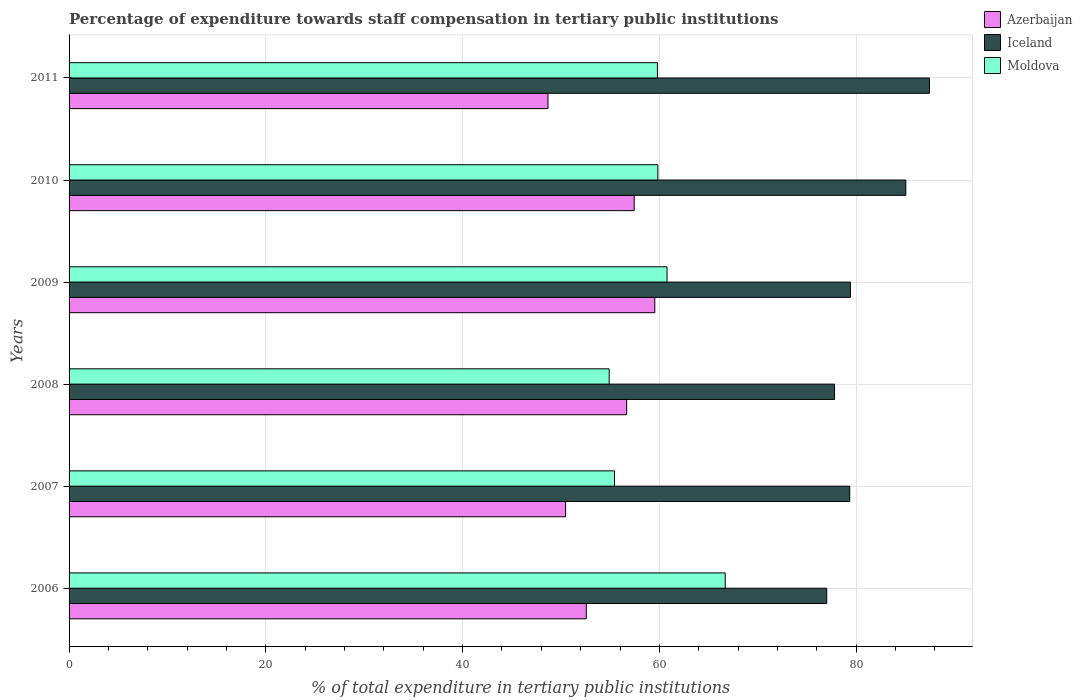How many different coloured bars are there?
Offer a very short reply. 3. How many bars are there on the 6th tick from the top?
Your answer should be very brief. 3. How many bars are there on the 4th tick from the bottom?
Your answer should be compact. 3. In how many cases, is the number of bars for a given year not equal to the number of legend labels?
Provide a short and direct response. 0. What is the percentage of expenditure towards staff compensation in Moldova in 2009?
Your response must be concise. 60.78. Across all years, what is the maximum percentage of expenditure towards staff compensation in Moldova?
Ensure brevity in your answer.  66.69. Across all years, what is the minimum percentage of expenditure towards staff compensation in Iceland?
Offer a very short reply. 77.01. In which year was the percentage of expenditure towards staff compensation in Moldova minimum?
Your response must be concise. 2008. What is the total percentage of expenditure towards staff compensation in Azerbaijan in the graph?
Your answer should be compact. 325.37. What is the difference between the percentage of expenditure towards staff compensation in Iceland in 2008 and that in 2010?
Make the answer very short. -7.24. What is the difference between the percentage of expenditure towards staff compensation in Azerbaijan in 2010 and the percentage of expenditure towards staff compensation in Iceland in 2011?
Ensure brevity in your answer.  -30.01. What is the average percentage of expenditure towards staff compensation in Iceland per year?
Your answer should be very brief. 81.01. In the year 2006, what is the difference between the percentage of expenditure towards staff compensation in Azerbaijan and percentage of expenditure towards staff compensation in Moldova?
Offer a terse response. -14.12. What is the ratio of the percentage of expenditure towards staff compensation in Moldova in 2007 to that in 2011?
Give a very brief answer. 0.93. Is the percentage of expenditure towards staff compensation in Azerbaijan in 2009 less than that in 2011?
Give a very brief answer. No. Is the difference between the percentage of expenditure towards staff compensation in Azerbaijan in 2008 and 2009 greater than the difference between the percentage of expenditure towards staff compensation in Moldova in 2008 and 2009?
Provide a succinct answer. Yes. What is the difference between the highest and the second highest percentage of expenditure towards staff compensation in Iceland?
Give a very brief answer. 2.4. What is the difference between the highest and the lowest percentage of expenditure towards staff compensation in Azerbaijan?
Ensure brevity in your answer.  10.86. What does the 2nd bar from the top in 2007 represents?
Offer a terse response. Iceland. What does the 2nd bar from the bottom in 2006 represents?
Your answer should be very brief. Iceland. How many years are there in the graph?
Your response must be concise. 6. Are the values on the major ticks of X-axis written in scientific E-notation?
Your answer should be very brief. No. How are the legend labels stacked?
Ensure brevity in your answer.  Vertical. What is the title of the graph?
Keep it short and to the point. Percentage of expenditure towards staff compensation in tertiary public institutions. What is the label or title of the X-axis?
Give a very brief answer. % of total expenditure in tertiary public institutions. What is the label or title of the Y-axis?
Keep it short and to the point. Years. What is the % of total expenditure in tertiary public institutions in Azerbaijan in 2006?
Give a very brief answer. 52.57. What is the % of total expenditure in tertiary public institutions in Iceland in 2006?
Offer a very short reply. 77.01. What is the % of total expenditure in tertiary public institutions in Moldova in 2006?
Provide a short and direct response. 66.69. What is the % of total expenditure in tertiary public institutions of Azerbaijan in 2007?
Ensure brevity in your answer.  50.47. What is the % of total expenditure in tertiary public institutions of Iceland in 2007?
Offer a terse response. 79.35. What is the % of total expenditure in tertiary public institutions of Moldova in 2007?
Provide a short and direct response. 55.44. What is the % of total expenditure in tertiary public institutions of Azerbaijan in 2008?
Provide a succinct answer. 56.67. What is the % of total expenditure in tertiary public institutions of Iceland in 2008?
Ensure brevity in your answer.  77.8. What is the % of total expenditure in tertiary public institutions of Moldova in 2008?
Provide a short and direct response. 54.9. What is the % of total expenditure in tertiary public institutions in Azerbaijan in 2009?
Provide a short and direct response. 59.54. What is the % of total expenditure in tertiary public institutions of Iceland in 2009?
Ensure brevity in your answer.  79.42. What is the % of total expenditure in tertiary public institutions in Moldova in 2009?
Provide a succinct answer. 60.78. What is the % of total expenditure in tertiary public institutions in Azerbaijan in 2010?
Provide a succinct answer. 57.44. What is the % of total expenditure in tertiary public institutions of Iceland in 2010?
Offer a terse response. 85.05. What is the % of total expenditure in tertiary public institutions of Moldova in 2010?
Make the answer very short. 59.85. What is the % of total expenditure in tertiary public institutions of Azerbaijan in 2011?
Your answer should be compact. 48.68. What is the % of total expenditure in tertiary public institutions of Iceland in 2011?
Give a very brief answer. 87.45. What is the % of total expenditure in tertiary public institutions in Moldova in 2011?
Make the answer very short. 59.8. Across all years, what is the maximum % of total expenditure in tertiary public institutions of Azerbaijan?
Your answer should be compact. 59.54. Across all years, what is the maximum % of total expenditure in tertiary public institutions in Iceland?
Make the answer very short. 87.45. Across all years, what is the maximum % of total expenditure in tertiary public institutions of Moldova?
Provide a succinct answer. 66.69. Across all years, what is the minimum % of total expenditure in tertiary public institutions of Azerbaijan?
Your response must be concise. 48.68. Across all years, what is the minimum % of total expenditure in tertiary public institutions of Iceland?
Offer a terse response. 77.01. Across all years, what is the minimum % of total expenditure in tertiary public institutions in Moldova?
Ensure brevity in your answer.  54.9. What is the total % of total expenditure in tertiary public institutions in Azerbaijan in the graph?
Your answer should be very brief. 325.37. What is the total % of total expenditure in tertiary public institutions in Iceland in the graph?
Your answer should be compact. 486.08. What is the total % of total expenditure in tertiary public institutions of Moldova in the graph?
Make the answer very short. 357.45. What is the difference between the % of total expenditure in tertiary public institutions of Azerbaijan in 2006 and that in 2007?
Your response must be concise. 2.1. What is the difference between the % of total expenditure in tertiary public institutions of Iceland in 2006 and that in 2007?
Ensure brevity in your answer.  -2.34. What is the difference between the % of total expenditure in tertiary public institutions in Moldova in 2006 and that in 2007?
Offer a very short reply. 11.25. What is the difference between the % of total expenditure in tertiary public institutions in Azerbaijan in 2006 and that in 2008?
Offer a very short reply. -4.1. What is the difference between the % of total expenditure in tertiary public institutions in Iceland in 2006 and that in 2008?
Provide a short and direct response. -0.79. What is the difference between the % of total expenditure in tertiary public institutions of Moldova in 2006 and that in 2008?
Your answer should be compact. 11.79. What is the difference between the % of total expenditure in tertiary public institutions of Azerbaijan in 2006 and that in 2009?
Provide a short and direct response. -6.96. What is the difference between the % of total expenditure in tertiary public institutions in Iceland in 2006 and that in 2009?
Give a very brief answer. -2.41. What is the difference between the % of total expenditure in tertiary public institutions of Moldova in 2006 and that in 2009?
Your response must be concise. 5.92. What is the difference between the % of total expenditure in tertiary public institutions in Azerbaijan in 2006 and that in 2010?
Provide a succinct answer. -4.87. What is the difference between the % of total expenditure in tertiary public institutions of Iceland in 2006 and that in 2010?
Your answer should be compact. -8.04. What is the difference between the % of total expenditure in tertiary public institutions in Moldova in 2006 and that in 2010?
Provide a short and direct response. 6.85. What is the difference between the % of total expenditure in tertiary public institutions of Azerbaijan in 2006 and that in 2011?
Make the answer very short. 3.89. What is the difference between the % of total expenditure in tertiary public institutions in Iceland in 2006 and that in 2011?
Keep it short and to the point. -10.44. What is the difference between the % of total expenditure in tertiary public institutions in Moldova in 2006 and that in 2011?
Provide a short and direct response. 6.89. What is the difference between the % of total expenditure in tertiary public institutions of Azerbaijan in 2007 and that in 2008?
Offer a very short reply. -6.2. What is the difference between the % of total expenditure in tertiary public institutions of Iceland in 2007 and that in 2008?
Your answer should be compact. 1.54. What is the difference between the % of total expenditure in tertiary public institutions of Moldova in 2007 and that in 2008?
Offer a very short reply. 0.54. What is the difference between the % of total expenditure in tertiary public institutions of Azerbaijan in 2007 and that in 2009?
Offer a terse response. -9.07. What is the difference between the % of total expenditure in tertiary public institutions of Iceland in 2007 and that in 2009?
Provide a short and direct response. -0.07. What is the difference between the % of total expenditure in tertiary public institutions of Moldova in 2007 and that in 2009?
Offer a very short reply. -5.34. What is the difference between the % of total expenditure in tertiary public institutions of Azerbaijan in 2007 and that in 2010?
Your answer should be very brief. -6.97. What is the difference between the % of total expenditure in tertiary public institutions of Iceland in 2007 and that in 2010?
Your answer should be very brief. -5.7. What is the difference between the % of total expenditure in tertiary public institutions of Moldova in 2007 and that in 2010?
Give a very brief answer. -4.41. What is the difference between the % of total expenditure in tertiary public institutions in Azerbaijan in 2007 and that in 2011?
Offer a terse response. 1.79. What is the difference between the % of total expenditure in tertiary public institutions in Iceland in 2007 and that in 2011?
Ensure brevity in your answer.  -8.1. What is the difference between the % of total expenditure in tertiary public institutions of Moldova in 2007 and that in 2011?
Offer a very short reply. -4.36. What is the difference between the % of total expenditure in tertiary public institutions in Azerbaijan in 2008 and that in 2009?
Ensure brevity in your answer.  -2.86. What is the difference between the % of total expenditure in tertiary public institutions in Iceland in 2008 and that in 2009?
Provide a short and direct response. -1.61. What is the difference between the % of total expenditure in tertiary public institutions of Moldova in 2008 and that in 2009?
Give a very brief answer. -5.88. What is the difference between the % of total expenditure in tertiary public institutions of Azerbaijan in 2008 and that in 2010?
Ensure brevity in your answer.  -0.77. What is the difference between the % of total expenditure in tertiary public institutions of Iceland in 2008 and that in 2010?
Ensure brevity in your answer.  -7.24. What is the difference between the % of total expenditure in tertiary public institutions in Moldova in 2008 and that in 2010?
Keep it short and to the point. -4.95. What is the difference between the % of total expenditure in tertiary public institutions in Azerbaijan in 2008 and that in 2011?
Your response must be concise. 7.99. What is the difference between the % of total expenditure in tertiary public institutions in Iceland in 2008 and that in 2011?
Provide a short and direct response. -9.65. What is the difference between the % of total expenditure in tertiary public institutions of Moldova in 2008 and that in 2011?
Provide a short and direct response. -4.9. What is the difference between the % of total expenditure in tertiary public institutions in Azerbaijan in 2009 and that in 2010?
Give a very brief answer. 2.09. What is the difference between the % of total expenditure in tertiary public institutions in Iceland in 2009 and that in 2010?
Your response must be concise. -5.63. What is the difference between the % of total expenditure in tertiary public institutions of Moldova in 2009 and that in 2010?
Ensure brevity in your answer.  0.93. What is the difference between the % of total expenditure in tertiary public institutions of Azerbaijan in 2009 and that in 2011?
Offer a terse response. 10.86. What is the difference between the % of total expenditure in tertiary public institutions in Iceland in 2009 and that in 2011?
Give a very brief answer. -8.04. What is the difference between the % of total expenditure in tertiary public institutions of Moldova in 2009 and that in 2011?
Offer a very short reply. 0.98. What is the difference between the % of total expenditure in tertiary public institutions of Azerbaijan in 2010 and that in 2011?
Make the answer very short. 8.76. What is the difference between the % of total expenditure in tertiary public institutions in Iceland in 2010 and that in 2011?
Provide a short and direct response. -2.4. What is the difference between the % of total expenditure in tertiary public institutions in Moldova in 2010 and that in 2011?
Keep it short and to the point. 0.04. What is the difference between the % of total expenditure in tertiary public institutions of Azerbaijan in 2006 and the % of total expenditure in tertiary public institutions of Iceland in 2007?
Provide a succinct answer. -26.78. What is the difference between the % of total expenditure in tertiary public institutions in Azerbaijan in 2006 and the % of total expenditure in tertiary public institutions in Moldova in 2007?
Your response must be concise. -2.87. What is the difference between the % of total expenditure in tertiary public institutions of Iceland in 2006 and the % of total expenditure in tertiary public institutions of Moldova in 2007?
Offer a terse response. 21.57. What is the difference between the % of total expenditure in tertiary public institutions in Azerbaijan in 2006 and the % of total expenditure in tertiary public institutions in Iceland in 2008?
Offer a terse response. -25.23. What is the difference between the % of total expenditure in tertiary public institutions of Azerbaijan in 2006 and the % of total expenditure in tertiary public institutions of Moldova in 2008?
Your answer should be very brief. -2.33. What is the difference between the % of total expenditure in tertiary public institutions of Iceland in 2006 and the % of total expenditure in tertiary public institutions of Moldova in 2008?
Offer a terse response. 22.11. What is the difference between the % of total expenditure in tertiary public institutions in Azerbaijan in 2006 and the % of total expenditure in tertiary public institutions in Iceland in 2009?
Your response must be concise. -26.85. What is the difference between the % of total expenditure in tertiary public institutions in Azerbaijan in 2006 and the % of total expenditure in tertiary public institutions in Moldova in 2009?
Your response must be concise. -8.21. What is the difference between the % of total expenditure in tertiary public institutions in Iceland in 2006 and the % of total expenditure in tertiary public institutions in Moldova in 2009?
Keep it short and to the point. 16.23. What is the difference between the % of total expenditure in tertiary public institutions of Azerbaijan in 2006 and the % of total expenditure in tertiary public institutions of Iceland in 2010?
Keep it short and to the point. -32.48. What is the difference between the % of total expenditure in tertiary public institutions of Azerbaijan in 2006 and the % of total expenditure in tertiary public institutions of Moldova in 2010?
Offer a terse response. -7.28. What is the difference between the % of total expenditure in tertiary public institutions in Iceland in 2006 and the % of total expenditure in tertiary public institutions in Moldova in 2010?
Keep it short and to the point. 17.16. What is the difference between the % of total expenditure in tertiary public institutions of Azerbaijan in 2006 and the % of total expenditure in tertiary public institutions of Iceland in 2011?
Your response must be concise. -34.88. What is the difference between the % of total expenditure in tertiary public institutions in Azerbaijan in 2006 and the % of total expenditure in tertiary public institutions in Moldova in 2011?
Keep it short and to the point. -7.23. What is the difference between the % of total expenditure in tertiary public institutions of Iceland in 2006 and the % of total expenditure in tertiary public institutions of Moldova in 2011?
Your answer should be compact. 17.21. What is the difference between the % of total expenditure in tertiary public institutions in Azerbaijan in 2007 and the % of total expenditure in tertiary public institutions in Iceland in 2008?
Your answer should be very brief. -27.34. What is the difference between the % of total expenditure in tertiary public institutions of Azerbaijan in 2007 and the % of total expenditure in tertiary public institutions of Moldova in 2008?
Give a very brief answer. -4.43. What is the difference between the % of total expenditure in tertiary public institutions of Iceland in 2007 and the % of total expenditure in tertiary public institutions of Moldova in 2008?
Give a very brief answer. 24.45. What is the difference between the % of total expenditure in tertiary public institutions of Azerbaijan in 2007 and the % of total expenditure in tertiary public institutions of Iceland in 2009?
Your response must be concise. -28.95. What is the difference between the % of total expenditure in tertiary public institutions in Azerbaijan in 2007 and the % of total expenditure in tertiary public institutions in Moldova in 2009?
Ensure brevity in your answer.  -10.31. What is the difference between the % of total expenditure in tertiary public institutions of Iceland in 2007 and the % of total expenditure in tertiary public institutions of Moldova in 2009?
Ensure brevity in your answer.  18.57. What is the difference between the % of total expenditure in tertiary public institutions in Azerbaijan in 2007 and the % of total expenditure in tertiary public institutions in Iceland in 2010?
Offer a very short reply. -34.58. What is the difference between the % of total expenditure in tertiary public institutions of Azerbaijan in 2007 and the % of total expenditure in tertiary public institutions of Moldova in 2010?
Your response must be concise. -9.38. What is the difference between the % of total expenditure in tertiary public institutions of Iceland in 2007 and the % of total expenditure in tertiary public institutions of Moldova in 2010?
Keep it short and to the point. 19.5. What is the difference between the % of total expenditure in tertiary public institutions of Azerbaijan in 2007 and the % of total expenditure in tertiary public institutions of Iceland in 2011?
Provide a succinct answer. -36.98. What is the difference between the % of total expenditure in tertiary public institutions in Azerbaijan in 2007 and the % of total expenditure in tertiary public institutions in Moldova in 2011?
Offer a terse response. -9.33. What is the difference between the % of total expenditure in tertiary public institutions in Iceland in 2007 and the % of total expenditure in tertiary public institutions in Moldova in 2011?
Your response must be concise. 19.55. What is the difference between the % of total expenditure in tertiary public institutions of Azerbaijan in 2008 and the % of total expenditure in tertiary public institutions of Iceland in 2009?
Keep it short and to the point. -22.74. What is the difference between the % of total expenditure in tertiary public institutions in Azerbaijan in 2008 and the % of total expenditure in tertiary public institutions in Moldova in 2009?
Your response must be concise. -4.1. What is the difference between the % of total expenditure in tertiary public institutions of Iceland in 2008 and the % of total expenditure in tertiary public institutions of Moldova in 2009?
Your response must be concise. 17.03. What is the difference between the % of total expenditure in tertiary public institutions of Azerbaijan in 2008 and the % of total expenditure in tertiary public institutions of Iceland in 2010?
Provide a succinct answer. -28.38. What is the difference between the % of total expenditure in tertiary public institutions of Azerbaijan in 2008 and the % of total expenditure in tertiary public institutions of Moldova in 2010?
Your answer should be very brief. -3.17. What is the difference between the % of total expenditure in tertiary public institutions in Iceland in 2008 and the % of total expenditure in tertiary public institutions in Moldova in 2010?
Offer a very short reply. 17.96. What is the difference between the % of total expenditure in tertiary public institutions of Azerbaijan in 2008 and the % of total expenditure in tertiary public institutions of Iceland in 2011?
Your answer should be compact. -30.78. What is the difference between the % of total expenditure in tertiary public institutions of Azerbaijan in 2008 and the % of total expenditure in tertiary public institutions of Moldova in 2011?
Your answer should be very brief. -3.13. What is the difference between the % of total expenditure in tertiary public institutions in Iceland in 2008 and the % of total expenditure in tertiary public institutions in Moldova in 2011?
Keep it short and to the point. 18. What is the difference between the % of total expenditure in tertiary public institutions of Azerbaijan in 2009 and the % of total expenditure in tertiary public institutions of Iceland in 2010?
Your response must be concise. -25.51. What is the difference between the % of total expenditure in tertiary public institutions in Azerbaijan in 2009 and the % of total expenditure in tertiary public institutions in Moldova in 2010?
Your response must be concise. -0.31. What is the difference between the % of total expenditure in tertiary public institutions of Iceland in 2009 and the % of total expenditure in tertiary public institutions of Moldova in 2010?
Give a very brief answer. 19.57. What is the difference between the % of total expenditure in tertiary public institutions of Azerbaijan in 2009 and the % of total expenditure in tertiary public institutions of Iceland in 2011?
Your answer should be very brief. -27.92. What is the difference between the % of total expenditure in tertiary public institutions in Azerbaijan in 2009 and the % of total expenditure in tertiary public institutions in Moldova in 2011?
Provide a short and direct response. -0.27. What is the difference between the % of total expenditure in tertiary public institutions in Iceland in 2009 and the % of total expenditure in tertiary public institutions in Moldova in 2011?
Provide a short and direct response. 19.62. What is the difference between the % of total expenditure in tertiary public institutions in Azerbaijan in 2010 and the % of total expenditure in tertiary public institutions in Iceland in 2011?
Your response must be concise. -30.01. What is the difference between the % of total expenditure in tertiary public institutions of Azerbaijan in 2010 and the % of total expenditure in tertiary public institutions of Moldova in 2011?
Offer a terse response. -2.36. What is the difference between the % of total expenditure in tertiary public institutions in Iceland in 2010 and the % of total expenditure in tertiary public institutions in Moldova in 2011?
Provide a succinct answer. 25.25. What is the average % of total expenditure in tertiary public institutions of Azerbaijan per year?
Your response must be concise. 54.23. What is the average % of total expenditure in tertiary public institutions in Iceland per year?
Give a very brief answer. 81.01. What is the average % of total expenditure in tertiary public institutions in Moldova per year?
Provide a succinct answer. 59.58. In the year 2006, what is the difference between the % of total expenditure in tertiary public institutions of Azerbaijan and % of total expenditure in tertiary public institutions of Iceland?
Provide a succinct answer. -24.44. In the year 2006, what is the difference between the % of total expenditure in tertiary public institutions of Azerbaijan and % of total expenditure in tertiary public institutions of Moldova?
Keep it short and to the point. -14.12. In the year 2006, what is the difference between the % of total expenditure in tertiary public institutions of Iceland and % of total expenditure in tertiary public institutions of Moldova?
Keep it short and to the point. 10.32. In the year 2007, what is the difference between the % of total expenditure in tertiary public institutions of Azerbaijan and % of total expenditure in tertiary public institutions of Iceland?
Make the answer very short. -28.88. In the year 2007, what is the difference between the % of total expenditure in tertiary public institutions in Azerbaijan and % of total expenditure in tertiary public institutions in Moldova?
Ensure brevity in your answer.  -4.97. In the year 2007, what is the difference between the % of total expenditure in tertiary public institutions of Iceland and % of total expenditure in tertiary public institutions of Moldova?
Provide a succinct answer. 23.91. In the year 2008, what is the difference between the % of total expenditure in tertiary public institutions in Azerbaijan and % of total expenditure in tertiary public institutions in Iceland?
Your response must be concise. -21.13. In the year 2008, what is the difference between the % of total expenditure in tertiary public institutions in Azerbaijan and % of total expenditure in tertiary public institutions in Moldova?
Your answer should be very brief. 1.77. In the year 2008, what is the difference between the % of total expenditure in tertiary public institutions in Iceland and % of total expenditure in tertiary public institutions in Moldova?
Your response must be concise. 22.91. In the year 2009, what is the difference between the % of total expenditure in tertiary public institutions of Azerbaijan and % of total expenditure in tertiary public institutions of Iceland?
Your response must be concise. -19.88. In the year 2009, what is the difference between the % of total expenditure in tertiary public institutions in Azerbaijan and % of total expenditure in tertiary public institutions in Moldova?
Offer a terse response. -1.24. In the year 2009, what is the difference between the % of total expenditure in tertiary public institutions in Iceland and % of total expenditure in tertiary public institutions in Moldova?
Keep it short and to the point. 18.64. In the year 2010, what is the difference between the % of total expenditure in tertiary public institutions of Azerbaijan and % of total expenditure in tertiary public institutions of Iceland?
Offer a very short reply. -27.61. In the year 2010, what is the difference between the % of total expenditure in tertiary public institutions of Azerbaijan and % of total expenditure in tertiary public institutions of Moldova?
Give a very brief answer. -2.4. In the year 2010, what is the difference between the % of total expenditure in tertiary public institutions in Iceland and % of total expenditure in tertiary public institutions in Moldova?
Your answer should be very brief. 25.2. In the year 2011, what is the difference between the % of total expenditure in tertiary public institutions of Azerbaijan and % of total expenditure in tertiary public institutions of Iceland?
Offer a very short reply. -38.77. In the year 2011, what is the difference between the % of total expenditure in tertiary public institutions of Azerbaijan and % of total expenditure in tertiary public institutions of Moldova?
Offer a very short reply. -11.12. In the year 2011, what is the difference between the % of total expenditure in tertiary public institutions in Iceland and % of total expenditure in tertiary public institutions in Moldova?
Make the answer very short. 27.65. What is the ratio of the % of total expenditure in tertiary public institutions in Azerbaijan in 2006 to that in 2007?
Your response must be concise. 1.04. What is the ratio of the % of total expenditure in tertiary public institutions in Iceland in 2006 to that in 2007?
Provide a short and direct response. 0.97. What is the ratio of the % of total expenditure in tertiary public institutions of Moldova in 2006 to that in 2007?
Give a very brief answer. 1.2. What is the ratio of the % of total expenditure in tertiary public institutions of Azerbaijan in 2006 to that in 2008?
Your response must be concise. 0.93. What is the ratio of the % of total expenditure in tertiary public institutions of Iceland in 2006 to that in 2008?
Your answer should be compact. 0.99. What is the ratio of the % of total expenditure in tertiary public institutions of Moldova in 2006 to that in 2008?
Your answer should be very brief. 1.21. What is the ratio of the % of total expenditure in tertiary public institutions in Azerbaijan in 2006 to that in 2009?
Your answer should be very brief. 0.88. What is the ratio of the % of total expenditure in tertiary public institutions in Iceland in 2006 to that in 2009?
Your response must be concise. 0.97. What is the ratio of the % of total expenditure in tertiary public institutions in Moldova in 2006 to that in 2009?
Provide a succinct answer. 1.1. What is the ratio of the % of total expenditure in tertiary public institutions of Azerbaijan in 2006 to that in 2010?
Provide a short and direct response. 0.92. What is the ratio of the % of total expenditure in tertiary public institutions of Iceland in 2006 to that in 2010?
Your answer should be compact. 0.91. What is the ratio of the % of total expenditure in tertiary public institutions in Moldova in 2006 to that in 2010?
Your answer should be compact. 1.11. What is the ratio of the % of total expenditure in tertiary public institutions of Azerbaijan in 2006 to that in 2011?
Provide a short and direct response. 1.08. What is the ratio of the % of total expenditure in tertiary public institutions of Iceland in 2006 to that in 2011?
Your answer should be compact. 0.88. What is the ratio of the % of total expenditure in tertiary public institutions of Moldova in 2006 to that in 2011?
Offer a very short reply. 1.12. What is the ratio of the % of total expenditure in tertiary public institutions in Azerbaijan in 2007 to that in 2008?
Keep it short and to the point. 0.89. What is the ratio of the % of total expenditure in tertiary public institutions in Iceland in 2007 to that in 2008?
Offer a very short reply. 1.02. What is the ratio of the % of total expenditure in tertiary public institutions in Moldova in 2007 to that in 2008?
Provide a short and direct response. 1.01. What is the ratio of the % of total expenditure in tertiary public institutions of Azerbaijan in 2007 to that in 2009?
Make the answer very short. 0.85. What is the ratio of the % of total expenditure in tertiary public institutions in Iceland in 2007 to that in 2009?
Provide a succinct answer. 1. What is the ratio of the % of total expenditure in tertiary public institutions of Moldova in 2007 to that in 2009?
Provide a succinct answer. 0.91. What is the ratio of the % of total expenditure in tertiary public institutions in Azerbaijan in 2007 to that in 2010?
Offer a terse response. 0.88. What is the ratio of the % of total expenditure in tertiary public institutions in Iceland in 2007 to that in 2010?
Your response must be concise. 0.93. What is the ratio of the % of total expenditure in tertiary public institutions of Moldova in 2007 to that in 2010?
Give a very brief answer. 0.93. What is the ratio of the % of total expenditure in tertiary public institutions of Azerbaijan in 2007 to that in 2011?
Your answer should be very brief. 1.04. What is the ratio of the % of total expenditure in tertiary public institutions of Iceland in 2007 to that in 2011?
Make the answer very short. 0.91. What is the ratio of the % of total expenditure in tertiary public institutions in Moldova in 2007 to that in 2011?
Provide a short and direct response. 0.93. What is the ratio of the % of total expenditure in tertiary public institutions of Azerbaijan in 2008 to that in 2009?
Keep it short and to the point. 0.95. What is the ratio of the % of total expenditure in tertiary public institutions of Iceland in 2008 to that in 2009?
Ensure brevity in your answer.  0.98. What is the ratio of the % of total expenditure in tertiary public institutions in Moldova in 2008 to that in 2009?
Your answer should be compact. 0.9. What is the ratio of the % of total expenditure in tertiary public institutions of Azerbaijan in 2008 to that in 2010?
Your response must be concise. 0.99. What is the ratio of the % of total expenditure in tertiary public institutions of Iceland in 2008 to that in 2010?
Make the answer very short. 0.91. What is the ratio of the % of total expenditure in tertiary public institutions of Moldova in 2008 to that in 2010?
Give a very brief answer. 0.92. What is the ratio of the % of total expenditure in tertiary public institutions in Azerbaijan in 2008 to that in 2011?
Give a very brief answer. 1.16. What is the ratio of the % of total expenditure in tertiary public institutions of Iceland in 2008 to that in 2011?
Ensure brevity in your answer.  0.89. What is the ratio of the % of total expenditure in tertiary public institutions in Moldova in 2008 to that in 2011?
Keep it short and to the point. 0.92. What is the ratio of the % of total expenditure in tertiary public institutions of Azerbaijan in 2009 to that in 2010?
Your answer should be very brief. 1.04. What is the ratio of the % of total expenditure in tertiary public institutions in Iceland in 2009 to that in 2010?
Offer a terse response. 0.93. What is the ratio of the % of total expenditure in tertiary public institutions in Moldova in 2009 to that in 2010?
Your response must be concise. 1.02. What is the ratio of the % of total expenditure in tertiary public institutions in Azerbaijan in 2009 to that in 2011?
Your response must be concise. 1.22. What is the ratio of the % of total expenditure in tertiary public institutions of Iceland in 2009 to that in 2011?
Your answer should be compact. 0.91. What is the ratio of the % of total expenditure in tertiary public institutions of Moldova in 2009 to that in 2011?
Keep it short and to the point. 1.02. What is the ratio of the % of total expenditure in tertiary public institutions in Azerbaijan in 2010 to that in 2011?
Provide a succinct answer. 1.18. What is the ratio of the % of total expenditure in tertiary public institutions of Iceland in 2010 to that in 2011?
Your response must be concise. 0.97. What is the difference between the highest and the second highest % of total expenditure in tertiary public institutions of Azerbaijan?
Keep it short and to the point. 2.09. What is the difference between the highest and the second highest % of total expenditure in tertiary public institutions of Iceland?
Provide a short and direct response. 2.4. What is the difference between the highest and the second highest % of total expenditure in tertiary public institutions in Moldova?
Your response must be concise. 5.92. What is the difference between the highest and the lowest % of total expenditure in tertiary public institutions of Azerbaijan?
Keep it short and to the point. 10.86. What is the difference between the highest and the lowest % of total expenditure in tertiary public institutions in Iceland?
Give a very brief answer. 10.44. What is the difference between the highest and the lowest % of total expenditure in tertiary public institutions of Moldova?
Make the answer very short. 11.79. 